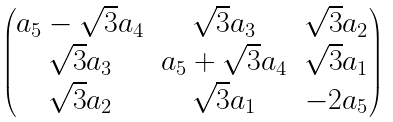<formula> <loc_0><loc_0><loc_500><loc_500>\begin{pmatrix} a _ { 5 } - \sqrt { 3 } a _ { 4 } & \sqrt { 3 } a _ { 3 } & \sqrt { 3 } a _ { 2 } \\ \sqrt { 3 } a _ { 3 } & a _ { 5 } + \sqrt { 3 } a _ { 4 } & \sqrt { 3 } a _ { 1 } \\ \sqrt { 3 } a _ { 2 } & \sqrt { 3 } a _ { 1 } & - 2 a _ { 5 } \end{pmatrix}</formula> 